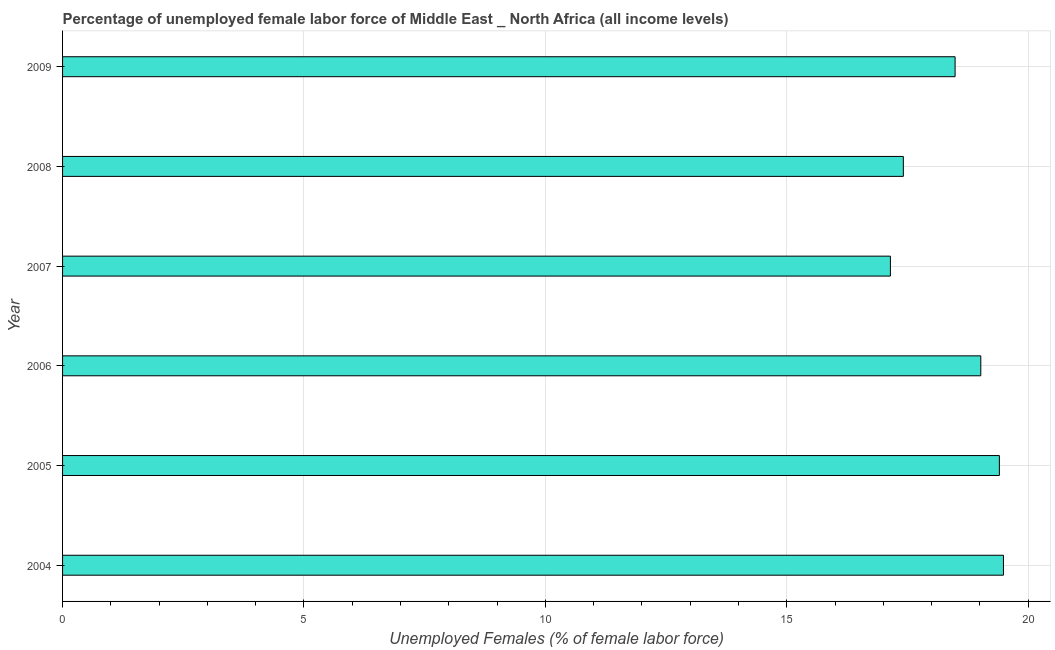What is the title of the graph?
Keep it short and to the point. Percentage of unemployed female labor force of Middle East _ North Africa (all income levels). What is the label or title of the X-axis?
Make the answer very short. Unemployed Females (% of female labor force). What is the total unemployed female labour force in 2004?
Offer a terse response. 19.49. Across all years, what is the maximum total unemployed female labour force?
Ensure brevity in your answer.  19.49. Across all years, what is the minimum total unemployed female labour force?
Your response must be concise. 17.15. In which year was the total unemployed female labour force maximum?
Your answer should be very brief. 2004. In which year was the total unemployed female labour force minimum?
Offer a terse response. 2007. What is the sum of the total unemployed female labour force?
Make the answer very short. 110.96. What is the difference between the total unemployed female labour force in 2007 and 2008?
Your answer should be compact. -0.27. What is the average total unemployed female labour force per year?
Make the answer very short. 18.49. What is the median total unemployed female labour force?
Make the answer very short. 18.75. In how many years, is the total unemployed female labour force greater than 5 %?
Give a very brief answer. 6. What is the ratio of the total unemployed female labour force in 2007 to that in 2009?
Make the answer very short. 0.93. What is the difference between the highest and the second highest total unemployed female labour force?
Make the answer very short. 0.08. Is the sum of the total unemployed female labour force in 2007 and 2009 greater than the maximum total unemployed female labour force across all years?
Your response must be concise. Yes. What is the difference between the highest and the lowest total unemployed female labour force?
Your answer should be compact. 2.34. How many years are there in the graph?
Your answer should be compact. 6. What is the difference between two consecutive major ticks on the X-axis?
Provide a short and direct response. 5. Are the values on the major ticks of X-axis written in scientific E-notation?
Ensure brevity in your answer.  No. What is the Unemployed Females (% of female labor force) in 2004?
Offer a very short reply. 19.49. What is the Unemployed Females (% of female labor force) of 2005?
Your response must be concise. 19.4. What is the Unemployed Females (% of female labor force) of 2006?
Make the answer very short. 19.02. What is the Unemployed Females (% of female labor force) of 2007?
Provide a succinct answer. 17.15. What is the Unemployed Females (% of female labor force) in 2008?
Provide a succinct answer. 17.41. What is the Unemployed Females (% of female labor force) in 2009?
Ensure brevity in your answer.  18.49. What is the difference between the Unemployed Females (% of female labor force) in 2004 and 2005?
Offer a very short reply. 0.08. What is the difference between the Unemployed Females (% of female labor force) in 2004 and 2006?
Your response must be concise. 0.47. What is the difference between the Unemployed Females (% of female labor force) in 2004 and 2007?
Make the answer very short. 2.34. What is the difference between the Unemployed Females (% of female labor force) in 2004 and 2008?
Offer a terse response. 2.07. What is the difference between the Unemployed Females (% of female labor force) in 2004 and 2009?
Your response must be concise. 1. What is the difference between the Unemployed Females (% of female labor force) in 2005 and 2006?
Keep it short and to the point. 0.38. What is the difference between the Unemployed Females (% of female labor force) in 2005 and 2007?
Your response must be concise. 2.26. What is the difference between the Unemployed Females (% of female labor force) in 2005 and 2008?
Ensure brevity in your answer.  1.99. What is the difference between the Unemployed Females (% of female labor force) in 2005 and 2009?
Keep it short and to the point. 0.92. What is the difference between the Unemployed Females (% of female labor force) in 2006 and 2007?
Your answer should be very brief. 1.87. What is the difference between the Unemployed Females (% of female labor force) in 2006 and 2008?
Your answer should be very brief. 1.6. What is the difference between the Unemployed Females (% of female labor force) in 2006 and 2009?
Provide a short and direct response. 0.53. What is the difference between the Unemployed Females (% of female labor force) in 2007 and 2008?
Your answer should be very brief. -0.27. What is the difference between the Unemployed Females (% of female labor force) in 2007 and 2009?
Make the answer very short. -1.34. What is the difference between the Unemployed Females (% of female labor force) in 2008 and 2009?
Ensure brevity in your answer.  -1.07. What is the ratio of the Unemployed Females (% of female labor force) in 2004 to that in 2005?
Your response must be concise. 1. What is the ratio of the Unemployed Females (% of female labor force) in 2004 to that in 2006?
Ensure brevity in your answer.  1.02. What is the ratio of the Unemployed Females (% of female labor force) in 2004 to that in 2007?
Provide a succinct answer. 1.14. What is the ratio of the Unemployed Females (% of female labor force) in 2004 to that in 2008?
Your response must be concise. 1.12. What is the ratio of the Unemployed Females (% of female labor force) in 2004 to that in 2009?
Keep it short and to the point. 1.05. What is the ratio of the Unemployed Females (% of female labor force) in 2005 to that in 2007?
Keep it short and to the point. 1.13. What is the ratio of the Unemployed Females (% of female labor force) in 2005 to that in 2008?
Ensure brevity in your answer.  1.11. What is the ratio of the Unemployed Females (% of female labor force) in 2006 to that in 2007?
Offer a very short reply. 1.11. What is the ratio of the Unemployed Females (% of female labor force) in 2006 to that in 2008?
Offer a very short reply. 1.09. What is the ratio of the Unemployed Females (% of female labor force) in 2007 to that in 2008?
Offer a terse response. 0.98. What is the ratio of the Unemployed Females (% of female labor force) in 2007 to that in 2009?
Keep it short and to the point. 0.93. What is the ratio of the Unemployed Females (% of female labor force) in 2008 to that in 2009?
Offer a terse response. 0.94. 